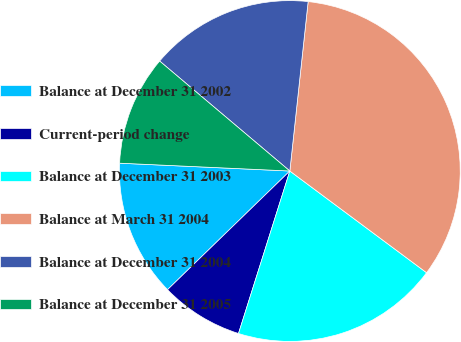Convert chart to OTSL. <chart><loc_0><loc_0><loc_500><loc_500><pie_chart><fcel>Balance at December 31 2002<fcel>Current-period change<fcel>Balance at December 31 2003<fcel>Balance at March 31 2004<fcel>Balance at December 31 2004<fcel>Balance at December 31 2005<nl><fcel>12.99%<fcel>7.87%<fcel>19.69%<fcel>33.46%<fcel>15.55%<fcel>10.43%<nl></chart> 